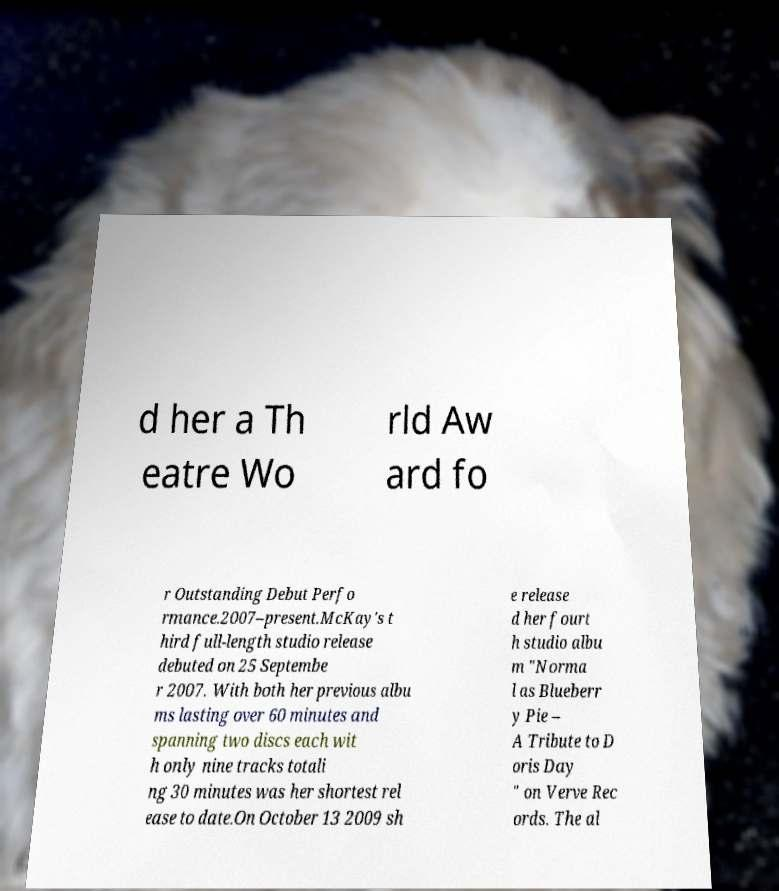Can you read and provide the text displayed in the image?This photo seems to have some interesting text. Can you extract and type it out for me? d her a Th eatre Wo rld Aw ard fo r Outstanding Debut Perfo rmance.2007–present.McKay's t hird full-length studio release debuted on 25 Septembe r 2007. With both her previous albu ms lasting over 60 minutes and spanning two discs each wit h only nine tracks totali ng 30 minutes was her shortest rel ease to date.On October 13 2009 sh e release d her fourt h studio albu m "Norma l as Blueberr y Pie – A Tribute to D oris Day " on Verve Rec ords. The al 